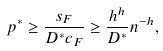Convert formula to latex. <formula><loc_0><loc_0><loc_500><loc_500>p ^ { * } \geq \frac { s _ { F } } { D ^ { * } c _ { F } } \geq \frac { h ^ { h } } { D ^ { * } } n ^ { - h } ,</formula> 